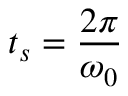<formula> <loc_0><loc_0><loc_500><loc_500>t _ { s } = \frac { 2 \pi } { \omega _ { 0 } }</formula> 